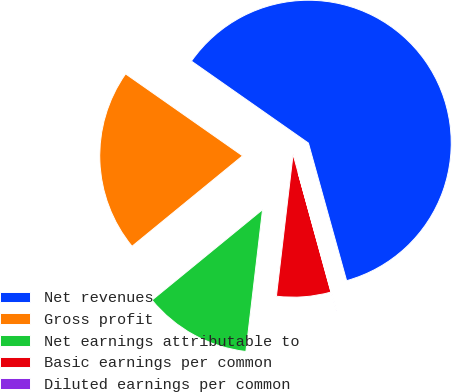<chart> <loc_0><loc_0><loc_500><loc_500><pie_chart><fcel>Net revenues<fcel>Gross profit<fcel>Net earnings attributable to<fcel>Basic earnings per common<fcel>Diluted earnings per common<nl><fcel>60.96%<fcel>20.64%<fcel>12.22%<fcel>6.13%<fcel>0.04%<nl></chart> 